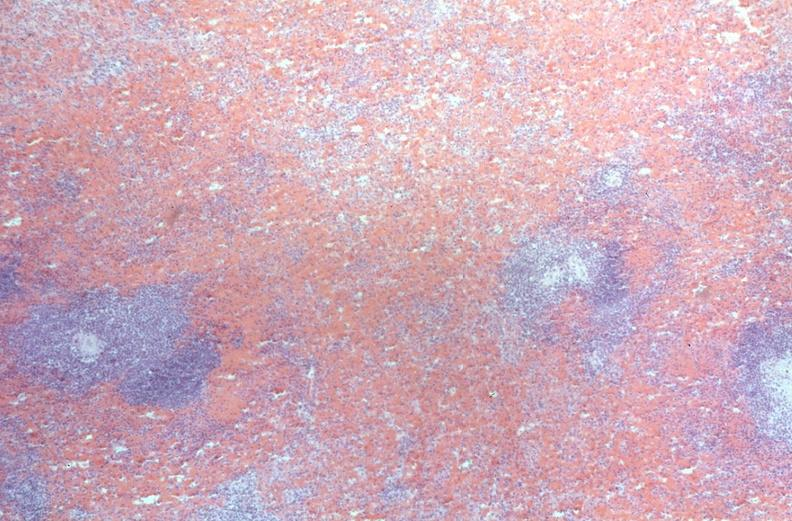does cat show spleen, congestion, congestive heart failure?
Answer the question using a single word or phrase. No 